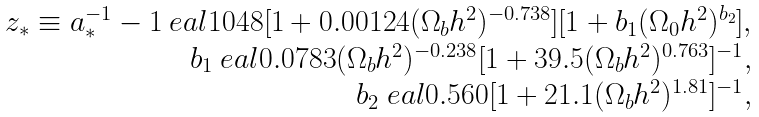Convert formula to latex. <formula><loc_0><loc_0><loc_500><loc_500>\begin{array} { r c l } z _ { * } \equiv a _ { * } ^ { - 1 } - 1 \ e a l 1 0 4 8 [ 1 + 0 . 0 0 1 2 4 ( \Omega _ { b } h ^ { 2 } ) ^ { - 0 . 7 3 8 } ] [ 1 + b _ { 1 } ( \Omega _ { 0 } h ^ { 2 } ) ^ { b _ { 2 } } ] , \\ b _ { 1 } \ e a l 0 . 0 7 8 3 ( \Omega _ { b } h ^ { 2 } ) ^ { - 0 . 2 3 8 } [ 1 + 3 9 . 5 ( \Omega _ { b } h ^ { 2 } ) ^ { 0 . 7 6 3 } ] ^ { - 1 } , \\ b _ { 2 } \ e a l 0 . 5 6 0 [ 1 + 2 1 . 1 ( \Omega _ { b } h ^ { 2 } ) ^ { 1 . 8 1 } ] ^ { - 1 } , \end{array}</formula> 